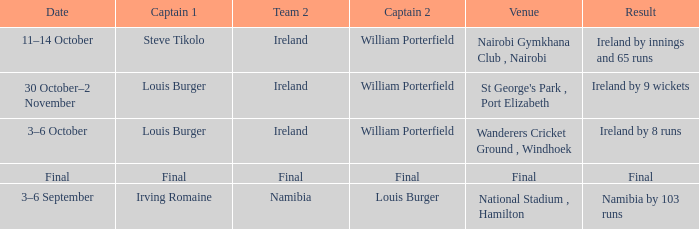Which Captain 2 has a Result of final? Final. 